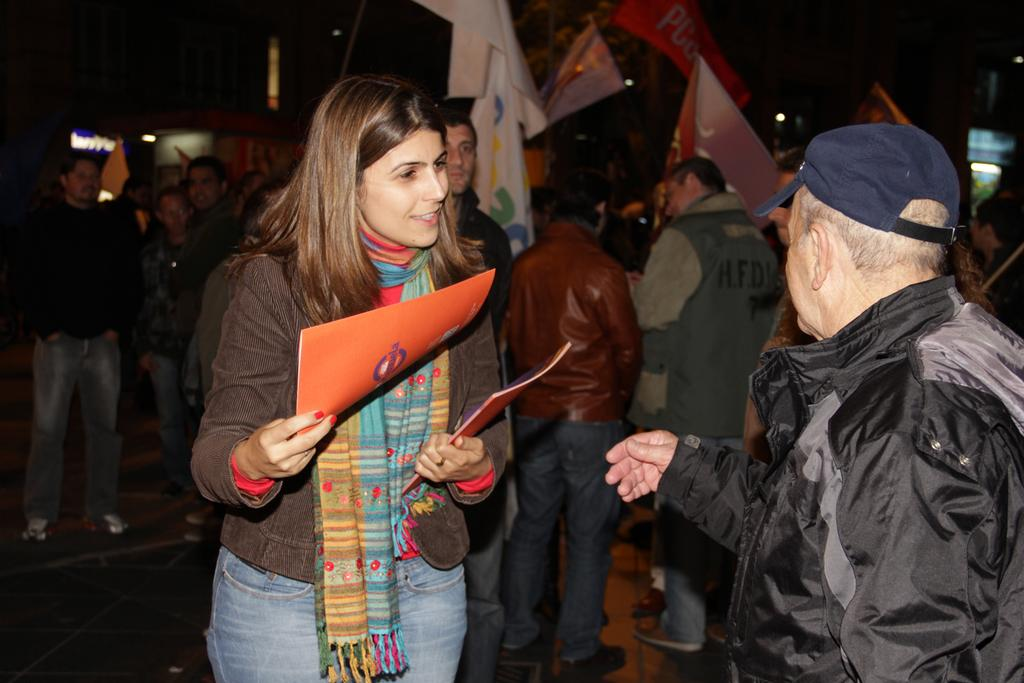What is the person holding in the image? There is a person holding an object in the image. Can you describe the person on the right side of the image? There is a person wearing a hat on the right side of the image. What can be seen in the background of the image? There are a few people in the background of the image. What else is visible in the image besides the people? There are flags visible in the image. What type of bread is being used to treat the disease in the image? There is no bread or disease present in the image. What story is being told by the people in the image? The image does not depict a story being told by the people; it simply shows them in a particular setting. 